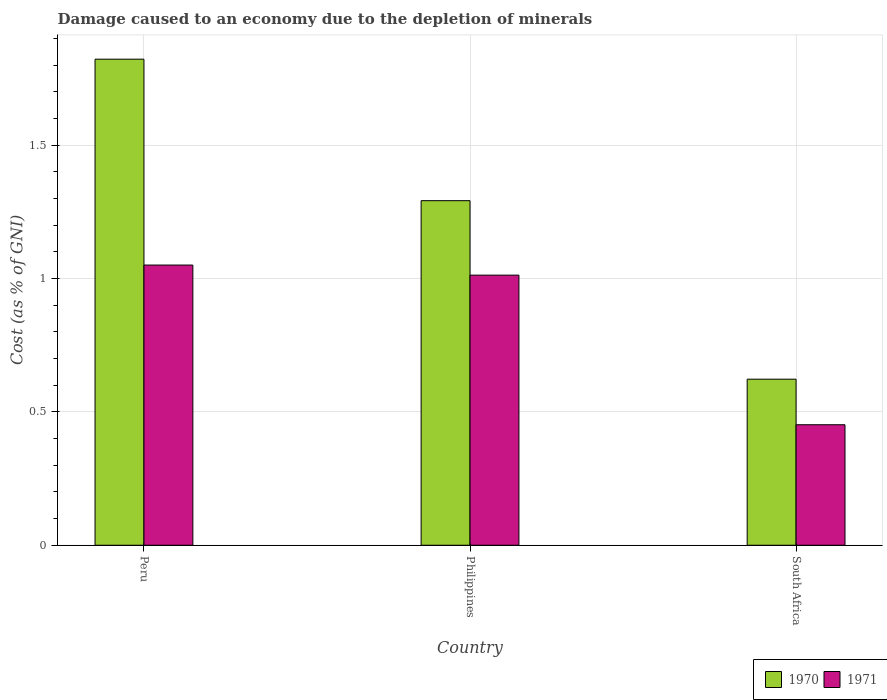How many different coloured bars are there?
Your answer should be compact. 2. Are the number of bars per tick equal to the number of legend labels?
Your response must be concise. Yes. Are the number of bars on each tick of the X-axis equal?
Give a very brief answer. Yes. In how many cases, is the number of bars for a given country not equal to the number of legend labels?
Offer a terse response. 0. What is the cost of damage caused due to the depletion of minerals in 1971 in Peru?
Your response must be concise. 1.05. Across all countries, what is the maximum cost of damage caused due to the depletion of minerals in 1971?
Provide a succinct answer. 1.05. Across all countries, what is the minimum cost of damage caused due to the depletion of minerals in 1971?
Offer a very short reply. 0.45. In which country was the cost of damage caused due to the depletion of minerals in 1971 minimum?
Offer a terse response. South Africa. What is the total cost of damage caused due to the depletion of minerals in 1971 in the graph?
Offer a terse response. 2.51. What is the difference between the cost of damage caused due to the depletion of minerals in 1970 in Philippines and that in South Africa?
Ensure brevity in your answer.  0.67. What is the difference between the cost of damage caused due to the depletion of minerals in 1971 in South Africa and the cost of damage caused due to the depletion of minerals in 1970 in Peru?
Give a very brief answer. -1.37. What is the average cost of damage caused due to the depletion of minerals in 1971 per country?
Provide a short and direct response. 0.84. What is the difference between the cost of damage caused due to the depletion of minerals of/in 1970 and cost of damage caused due to the depletion of minerals of/in 1971 in Philippines?
Your response must be concise. 0.28. What is the ratio of the cost of damage caused due to the depletion of minerals in 1970 in Peru to that in South Africa?
Make the answer very short. 2.93. Is the cost of damage caused due to the depletion of minerals in 1971 in Peru less than that in Philippines?
Give a very brief answer. No. Is the difference between the cost of damage caused due to the depletion of minerals in 1970 in Peru and Philippines greater than the difference between the cost of damage caused due to the depletion of minerals in 1971 in Peru and Philippines?
Offer a terse response. Yes. What is the difference between the highest and the second highest cost of damage caused due to the depletion of minerals in 1970?
Offer a very short reply. -1.2. What is the difference between the highest and the lowest cost of damage caused due to the depletion of minerals in 1971?
Your response must be concise. 0.6. In how many countries, is the cost of damage caused due to the depletion of minerals in 1970 greater than the average cost of damage caused due to the depletion of minerals in 1970 taken over all countries?
Ensure brevity in your answer.  2. What does the 2nd bar from the right in South Africa represents?
Provide a succinct answer. 1970. How many bars are there?
Your answer should be very brief. 6. How many countries are there in the graph?
Offer a terse response. 3. What is the difference between two consecutive major ticks on the Y-axis?
Provide a succinct answer. 0.5. Are the values on the major ticks of Y-axis written in scientific E-notation?
Your answer should be compact. No. What is the title of the graph?
Give a very brief answer. Damage caused to an economy due to the depletion of minerals. What is the label or title of the X-axis?
Offer a very short reply. Country. What is the label or title of the Y-axis?
Keep it short and to the point. Cost (as % of GNI). What is the Cost (as % of GNI) in 1970 in Peru?
Your answer should be very brief. 1.82. What is the Cost (as % of GNI) in 1971 in Peru?
Ensure brevity in your answer.  1.05. What is the Cost (as % of GNI) in 1970 in Philippines?
Provide a short and direct response. 1.29. What is the Cost (as % of GNI) of 1971 in Philippines?
Offer a terse response. 1.01. What is the Cost (as % of GNI) of 1970 in South Africa?
Keep it short and to the point. 0.62. What is the Cost (as % of GNI) of 1971 in South Africa?
Keep it short and to the point. 0.45. Across all countries, what is the maximum Cost (as % of GNI) of 1970?
Your answer should be compact. 1.82. Across all countries, what is the maximum Cost (as % of GNI) in 1971?
Ensure brevity in your answer.  1.05. Across all countries, what is the minimum Cost (as % of GNI) of 1970?
Provide a succinct answer. 0.62. Across all countries, what is the minimum Cost (as % of GNI) of 1971?
Provide a short and direct response. 0.45. What is the total Cost (as % of GNI) of 1970 in the graph?
Give a very brief answer. 3.74. What is the total Cost (as % of GNI) in 1971 in the graph?
Your response must be concise. 2.51. What is the difference between the Cost (as % of GNI) of 1970 in Peru and that in Philippines?
Your answer should be compact. 0.53. What is the difference between the Cost (as % of GNI) of 1971 in Peru and that in Philippines?
Offer a very short reply. 0.04. What is the difference between the Cost (as % of GNI) in 1970 in Peru and that in South Africa?
Offer a very short reply. 1.2. What is the difference between the Cost (as % of GNI) of 1971 in Peru and that in South Africa?
Your answer should be compact. 0.6. What is the difference between the Cost (as % of GNI) in 1970 in Philippines and that in South Africa?
Ensure brevity in your answer.  0.67. What is the difference between the Cost (as % of GNI) of 1971 in Philippines and that in South Africa?
Offer a very short reply. 0.56. What is the difference between the Cost (as % of GNI) of 1970 in Peru and the Cost (as % of GNI) of 1971 in Philippines?
Your answer should be very brief. 0.81. What is the difference between the Cost (as % of GNI) of 1970 in Peru and the Cost (as % of GNI) of 1971 in South Africa?
Provide a succinct answer. 1.37. What is the difference between the Cost (as % of GNI) in 1970 in Philippines and the Cost (as % of GNI) in 1971 in South Africa?
Make the answer very short. 0.84. What is the average Cost (as % of GNI) of 1970 per country?
Offer a terse response. 1.25. What is the average Cost (as % of GNI) of 1971 per country?
Make the answer very short. 0.84. What is the difference between the Cost (as % of GNI) of 1970 and Cost (as % of GNI) of 1971 in Peru?
Make the answer very short. 0.77. What is the difference between the Cost (as % of GNI) of 1970 and Cost (as % of GNI) of 1971 in Philippines?
Offer a very short reply. 0.28. What is the difference between the Cost (as % of GNI) in 1970 and Cost (as % of GNI) in 1971 in South Africa?
Your answer should be compact. 0.17. What is the ratio of the Cost (as % of GNI) of 1970 in Peru to that in Philippines?
Your answer should be compact. 1.41. What is the ratio of the Cost (as % of GNI) in 1971 in Peru to that in Philippines?
Offer a very short reply. 1.04. What is the ratio of the Cost (as % of GNI) in 1970 in Peru to that in South Africa?
Provide a succinct answer. 2.93. What is the ratio of the Cost (as % of GNI) in 1971 in Peru to that in South Africa?
Provide a succinct answer. 2.33. What is the ratio of the Cost (as % of GNI) of 1970 in Philippines to that in South Africa?
Keep it short and to the point. 2.07. What is the ratio of the Cost (as % of GNI) in 1971 in Philippines to that in South Africa?
Offer a terse response. 2.24. What is the difference between the highest and the second highest Cost (as % of GNI) in 1970?
Ensure brevity in your answer.  0.53. What is the difference between the highest and the second highest Cost (as % of GNI) in 1971?
Keep it short and to the point. 0.04. What is the difference between the highest and the lowest Cost (as % of GNI) in 1970?
Your answer should be very brief. 1.2. What is the difference between the highest and the lowest Cost (as % of GNI) of 1971?
Keep it short and to the point. 0.6. 